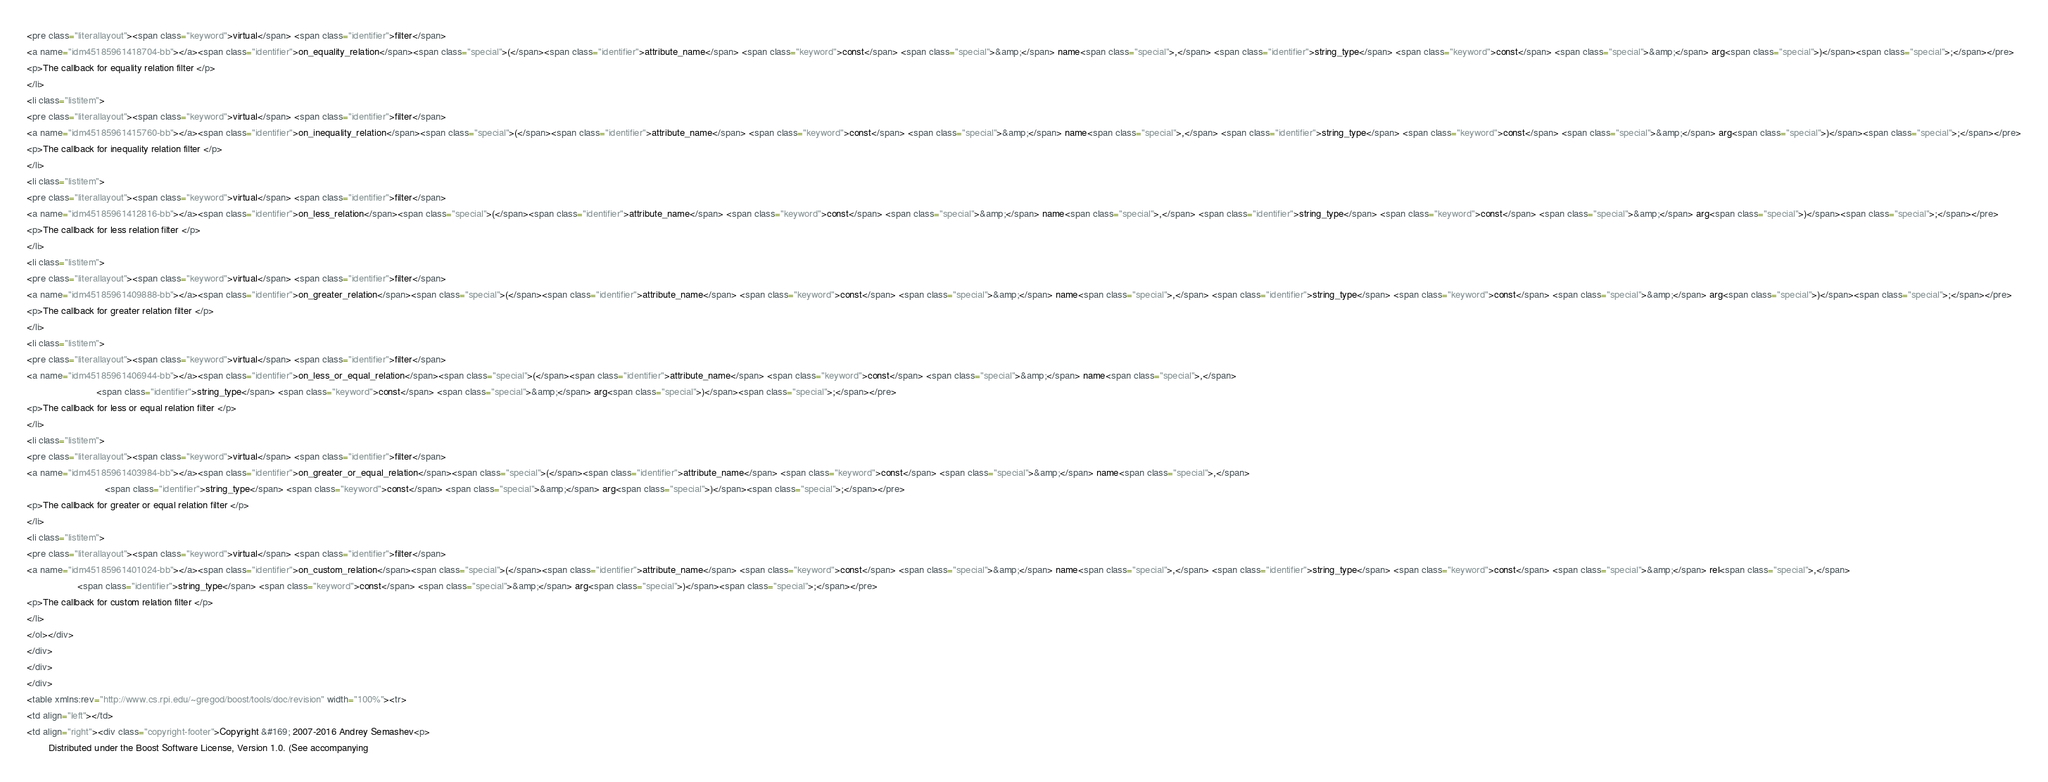Convert code to text. <code><loc_0><loc_0><loc_500><loc_500><_HTML_><pre class="literallayout"><span class="keyword">virtual</span> <span class="identifier">filter</span> 
<a name="idm45185961418704-bb"></a><span class="identifier">on_equality_relation</span><span class="special">(</span><span class="identifier">attribute_name</span> <span class="keyword">const</span> <span class="special">&amp;</span> name<span class="special">,</span> <span class="identifier">string_type</span> <span class="keyword">const</span> <span class="special">&amp;</span> arg<span class="special">)</span><span class="special">;</span></pre>
<p>The callback for equality relation filter </p>
</li>
<li class="listitem">
<pre class="literallayout"><span class="keyword">virtual</span> <span class="identifier">filter</span> 
<a name="idm45185961415760-bb"></a><span class="identifier">on_inequality_relation</span><span class="special">(</span><span class="identifier">attribute_name</span> <span class="keyword">const</span> <span class="special">&amp;</span> name<span class="special">,</span> <span class="identifier">string_type</span> <span class="keyword">const</span> <span class="special">&amp;</span> arg<span class="special">)</span><span class="special">;</span></pre>
<p>The callback for inequality relation filter </p>
</li>
<li class="listitem">
<pre class="literallayout"><span class="keyword">virtual</span> <span class="identifier">filter</span> 
<a name="idm45185961412816-bb"></a><span class="identifier">on_less_relation</span><span class="special">(</span><span class="identifier">attribute_name</span> <span class="keyword">const</span> <span class="special">&amp;</span> name<span class="special">,</span> <span class="identifier">string_type</span> <span class="keyword">const</span> <span class="special">&amp;</span> arg<span class="special">)</span><span class="special">;</span></pre>
<p>The callback for less relation filter </p>
</li>
<li class="listitem">
<pre class="literallayout"><span class="keyword">virtual</span> <span class="identifier">filter</span> 
<a name="idm45185961409888-bb"></a><span class="identifier">on_greater_relation</span><span class="special">(</span><span class="identifier">attribute_name</span> <span class="keyword">const</span> <span class="special">&amp;</span> name<span class="special">,</span> <span class="identifier">string_type</span> <span class="keyword">const</span> <span class="special">&amp;</span> arg<span class="special">)</span><span class="special">;</span></pre>
<p>The callback for greater relation filter </p>
</li>
<li class="listitem">
<pre class="literallayout"><span class="keyword">virtual</span> <span class="identifier">filter</span> 
<a name="idm45185961406944-bb"></a><span class="identifier">on_less_or_equal_relation</span><span class="special">(</span><span class="identifier">attribute_name</span> <span class="keyword">const</span> <span class="special">&amp;</span> name<span class="special">,</span> 
                          <span class="identifier">string_type</span> <span class="keyword">const</span> <span class="special">&amp;</span> arg<span class="special">)</span><span class="special">;</span></pre>
<p>The callback for less or equal relation filter </p>
</li>
<li class="listitem">
<pre class="literallayout"><span class="keyword">virtual</span> <span class="identifier">filter</span> 
<a name="idm45185961403984-bb"></a><span class="identifier">on_greater_or_equal_relation</span><span class="special">(</span><span class="identifier">attribute_name</span> <span class="keyword">const</span> <span class="special">&amp;</span> name<span class="special">,</span> 
                             <span class="identifier">string_type</span> <span class="keyword">const</span> <span class="special">&amp;</span> arg<span class="special">)</span><span class="special">;</span></pre>
<p>The callback for greater or equal relation filter </p>
</li>
<li class="listitem">
<pre class="literallayout"><span class="keyword">virtual</span> <span class="identifier">filter</span> 
<a name="idm45185961401024-bb"></a><span class="identifier">on_custom_relation</span><span class="special">(</span><span class="identifier">attribute_name</span> <span class="keyword">const</span> <span class="special">&amp;</span> name<span class="special">,</span> <span class="identifier">string_type</span> <span class="keyword">const</span> <span class="special">&amp;</span> rel<span class="special">,</span> 
                   <span class="identifier">string_type</span> <span class="keyword">const</span> <span class="special">&amp;</span> arg<span class="special">)</span><span class="special">;</span></pre>
<p>The callback for custom relation filter </p>
</li>
</ol></div>
</div>
</div>
</div>
<table xmlns:rev="http://www.cs.rpi.edu/~gregod/boost/tools/doc/revision" width="100%"><tr>
<td align="left"></td>
<td align="right"><div class="copyright-footer">Copyright &#169; 2007-2016 Andrey Semashev<p>
        Distributed under the Boost Software License, Version 1.0. (See accompanying</code> 